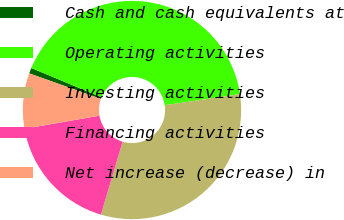Convert chart. <chart><loc_0><loc_0><loc_500><loc_500><pie_chart><fcel>Cash and cash equivalents at<fcel>Operating activities<fcel>Investing activities<fcel>Financing activities<fcel>Net increase (decrease) in<nl><fcel>0.84%<fcel>41.38%<fcel>31.92%<fcel>17.66%<fcel>8.2%<nl></chart> 